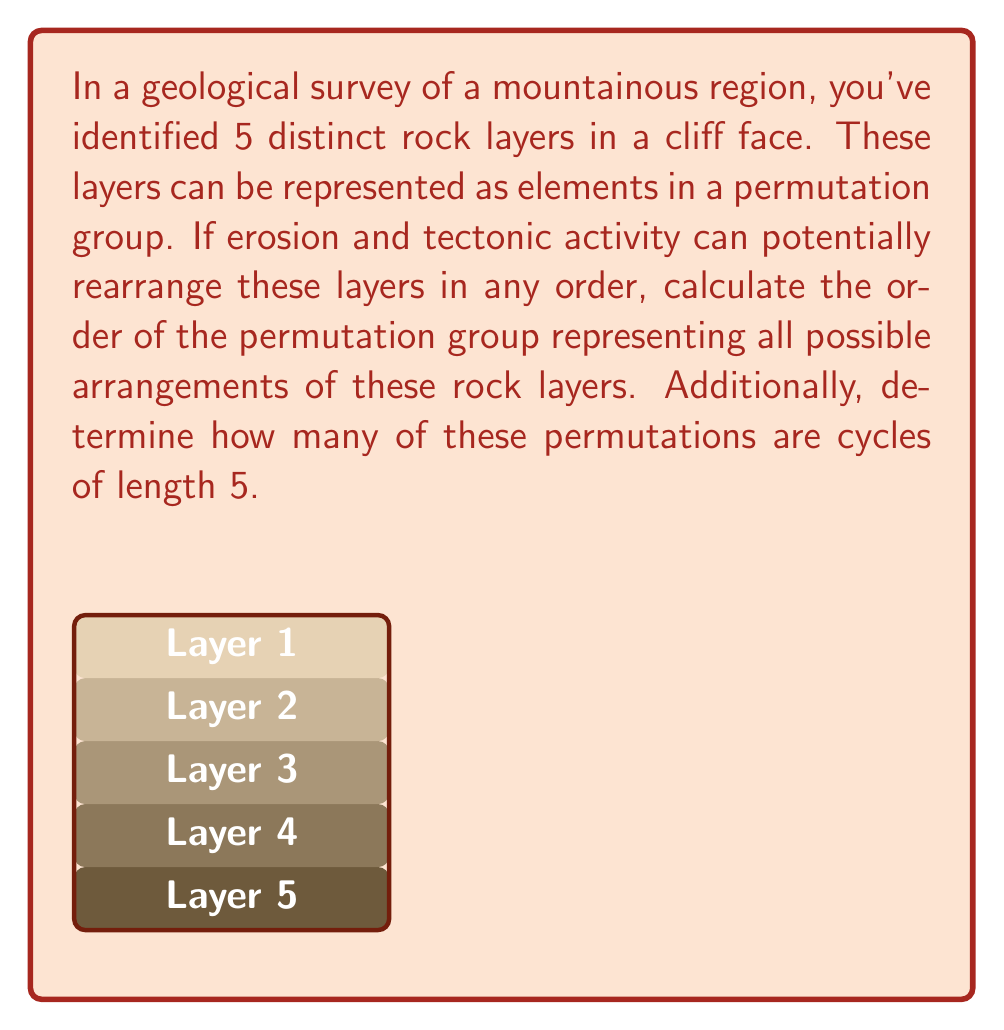Help me with this question. Let's approach this step-by-step:

1) The order of a permutation group is the number of distinct permutations possible. For n distinct elements, this is given by n!.

2) In this case, we have 5 distinct rock layers. Therefore, the order of the permutation group is:

   $$5! = 5 \times 4 \times 3 \times 2 \times 1 = 120$$

3) Now, for the second part of the question, we need to determine how many of these permutations are cycles of length 5.

4) A cycle of length 5 is a permutation that moves all 5 elements in a cyclic manner. For example, (12345) or (15432).

5) To count these, we can use the following reasoning:
   - We have 5 choices for the first element in the cycle
   - After that, we have 4 choices for the second element
   - Then 3 for the third, 2 for the fourth
   - The last element is forced (as it must connect back to the first)

6) Therefore, the number of 5-cycles is:

   $$5 \times 4 \times 3 \times 2 = 120$$

7) We divide by 5 because each cycle can be written 5 different ways (rotating the starting point). For example, (12345) = (23451) = (34512) = (45123) = (51234).

8) So, the final count of 5-cycles is:

   $$\frac{120}{5} = 24$$

This result aligns with the geological context, as it represents the number of ways the rock layers could be completely rearranged in a single cyclic permutation.
Answer: Order of permutation group: 120; Number of 5-cycles: 24 